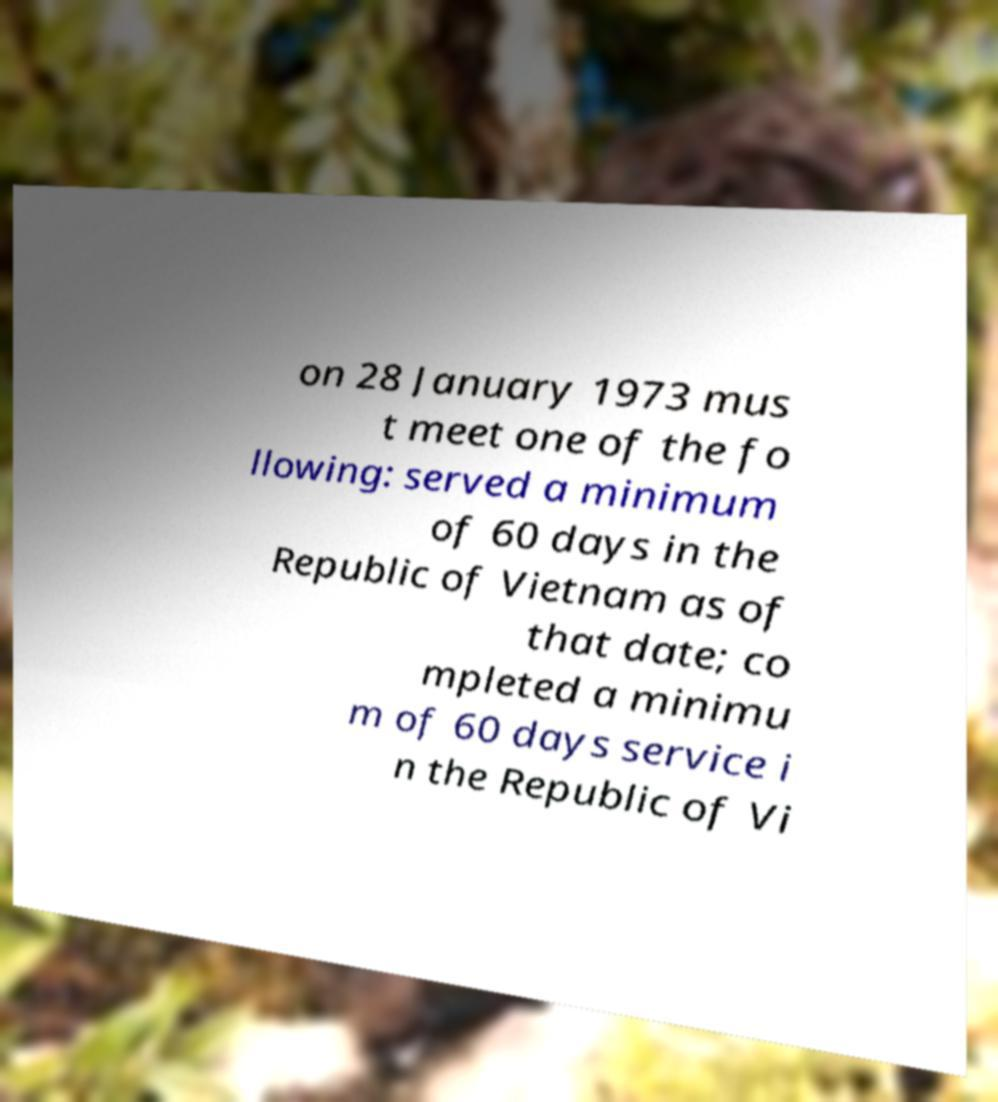Can you read and provide the text displayed in the image?This photo seems to have some interesting text. Can you extract and type it out for me? on 28 January 1973 mus t meet one of the fo llowing: served a minimum of 60 days in the Republic of Vietnam as of that date; co mpleted a minimu m of 60 days service i n the Republic of Vi 